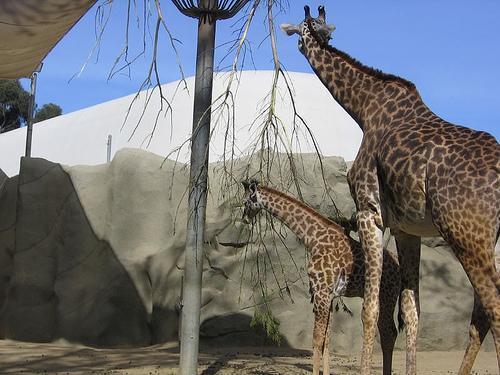How many animals?
Give a very brief answer. 2. How many giraffes are there?
Give a very brief answer. 2. How many giraffes are in the photo?
Give a very brief answer. 2. 